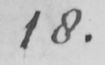What text is written in this handwritten line? 18. 